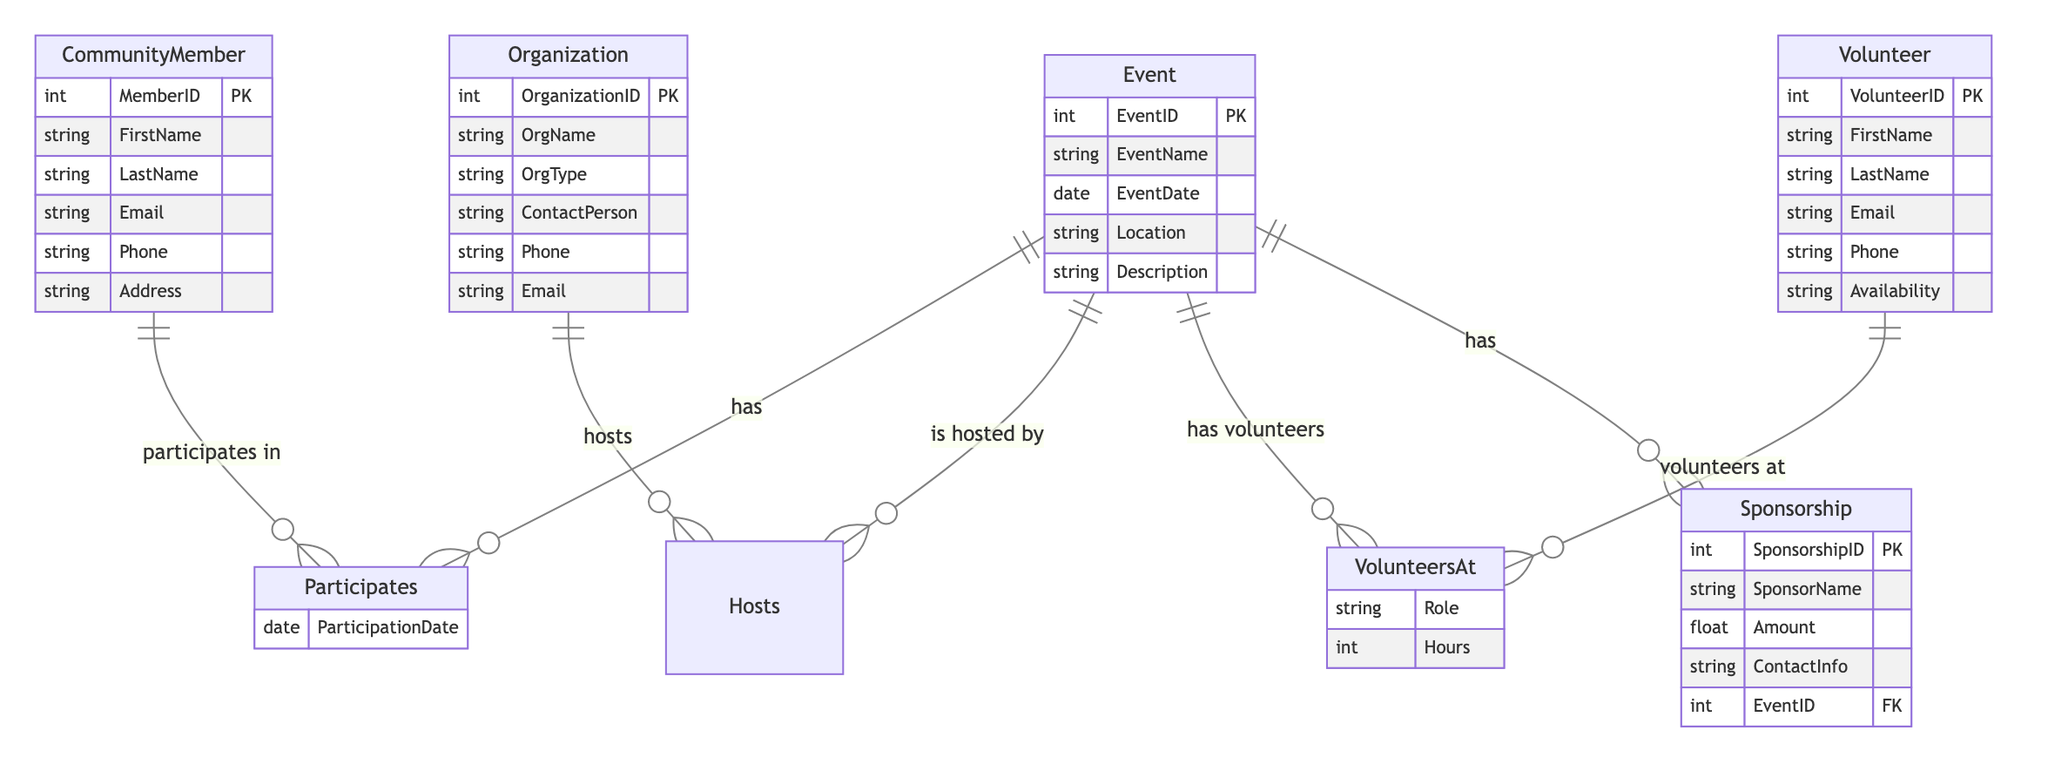What is the primary relationship between CommunityMember and Event? The primary relationship is "Participates," indicating that a CommunityMember takes part in an Event.
Answer: Participates How many attributes does the Event entity have? The Event entity has five attributes: EventID, EventName, EventDate, Location, and Description.
Answer: Five What is the relationship type between Organization and Event? The relationship type is "Hosts," meaning that an Organization can host an Event.
Answer: Hosts How many entities are involved in the diagram? There are five entities in the diagram: CommunityMember, Event, Volunteer, Sponsorship, and Organization.
Answer: Five What attribute indicates the role of a Volunteer at an Event? The attribute that indicates the role of a Volunteer at an Event is "Role."
Answer: Role In what context does the Sponsorship entity relate to Event? The Sponsorship entity relates to Event using "has," which signifies that an Event can have multiple Sponsorships.
Answer: has How many relationships connect to the Volunteer entity? The Volunteer entity connects to one relationship: "VolunteersAt," linking it to the Event.
Answer: One What additional information is captured in the Participates relationship? The Participates relationship captures an additional attribute called "ParticipationDate."
Answer: ParticipationDate Which entity includes the attribute 'ContactPerson'? The Organization entity includes the attribute 'ContactPerson.'
Answer: Organization 